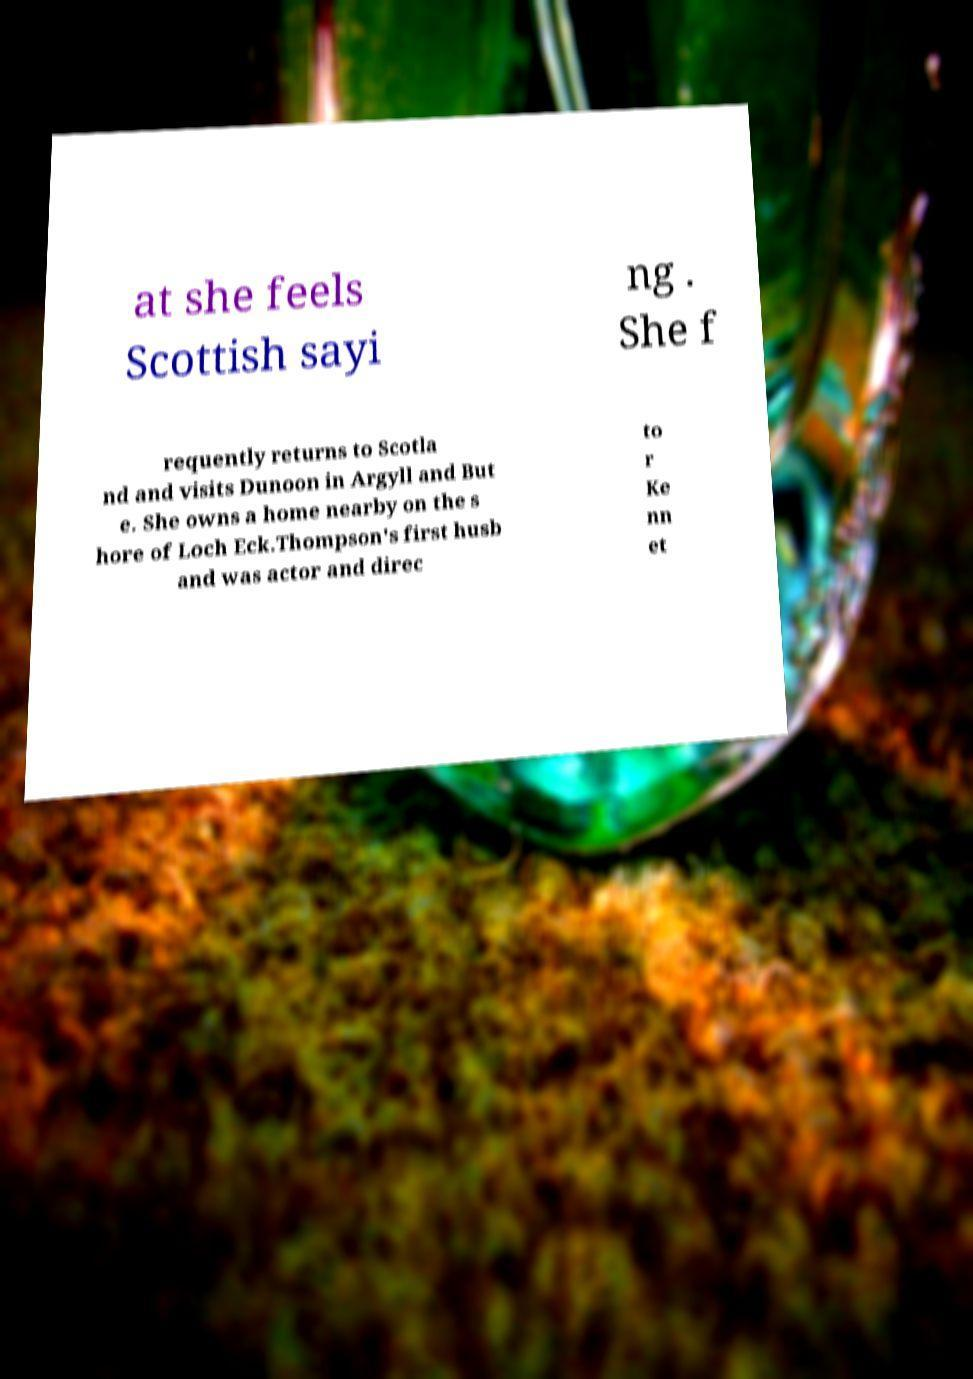Could you extract and type out the text from this image? at she feels Scottish sayi ng . She f requently returns to Scotla nd and visits Dunoon in Argyll and But e. She owns a home nearby on the s hore of Loch Eck.Thompson's first husb and was actor and direc to r Ke nn et 